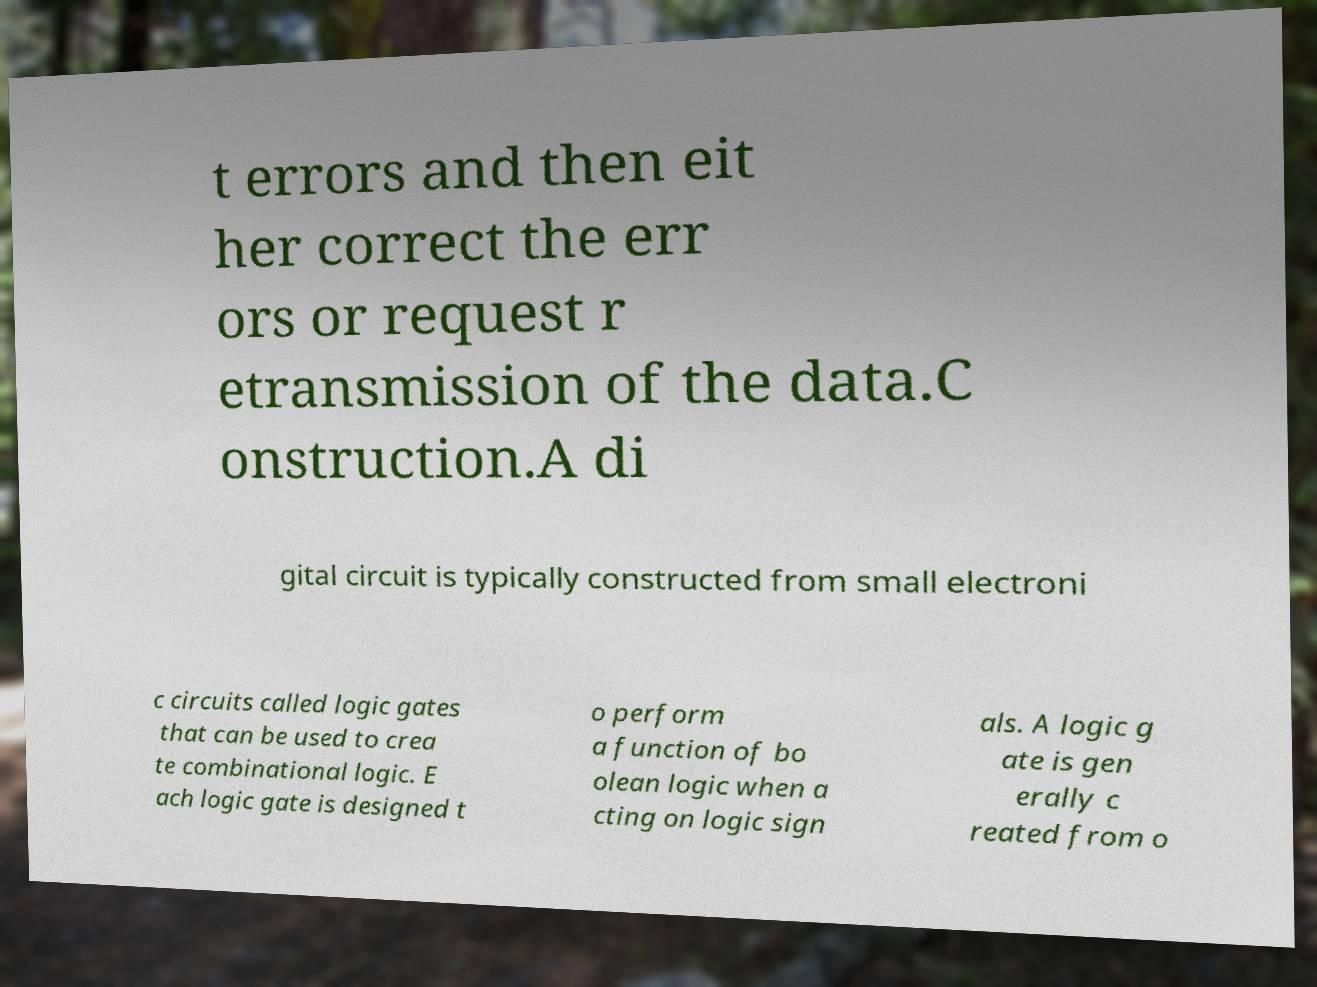Can you accurately transcribe the text from the provided image for me? t errors and then eit her correct the err ors or request r etransmission of the data.C onstruction.A di gital circuit is typically constructed from small electroni c circuits called logic gates that can be used to crea te combinational logic. E ach logic gate is designed t o perform a function of bo olean logic when a cting on logic sign als. A logic g ate is gen erally c reated from o 